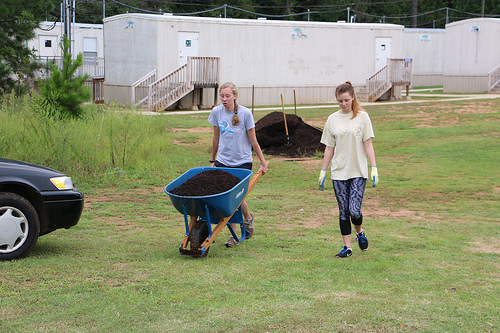<image>
Is the woman to the right of the woman? Yes. From this viewpoint, the woman is positioned to the right side relative to the woman. Is there a girl in front of the carrier? No. The girl is not in front of the carrier. The spatial positioning shows a different relationship between these objects. 